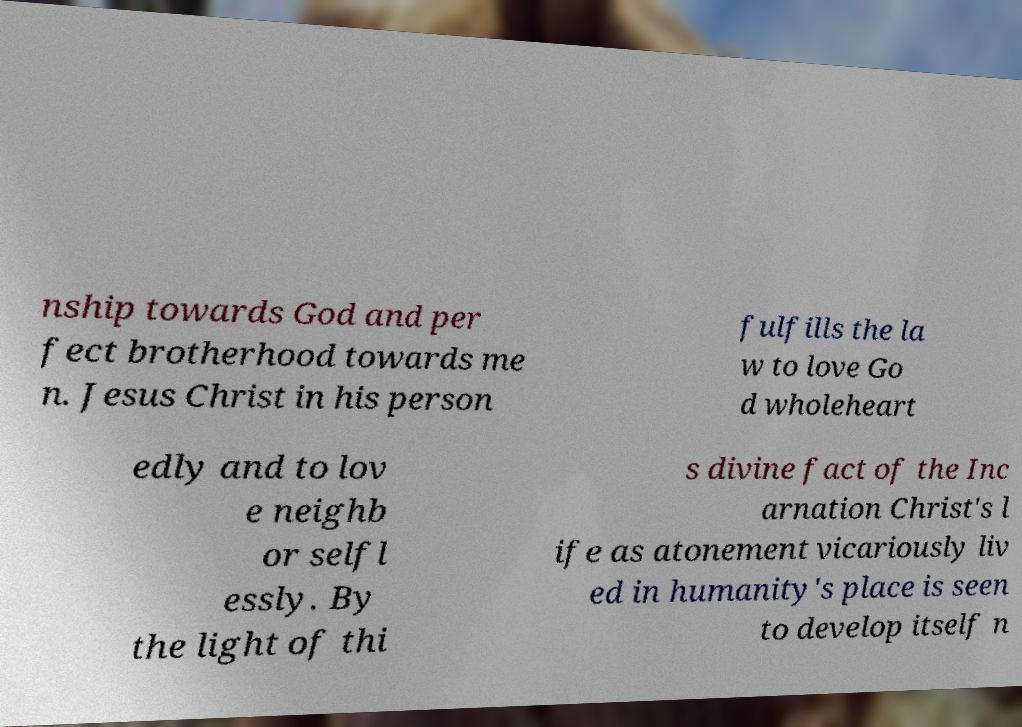Please read and relay the text visible in this image. What does it say? nship towards God and per fect brotherhood towards me n. Jesus Christ in his person fulfills the la w to love Go d wholeheart edly and to lov e neighb or selfl essly. By the light of thi s divine fact of the Inc arnation Christ's l ife as atonement vicariously liv ed in humanity's place is seen to develop itself n 